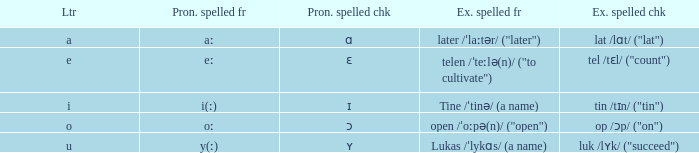What is Pronunciation Spelled Free, when Pronunciation Spelled Checked is "ʏ"? Y(ː). 